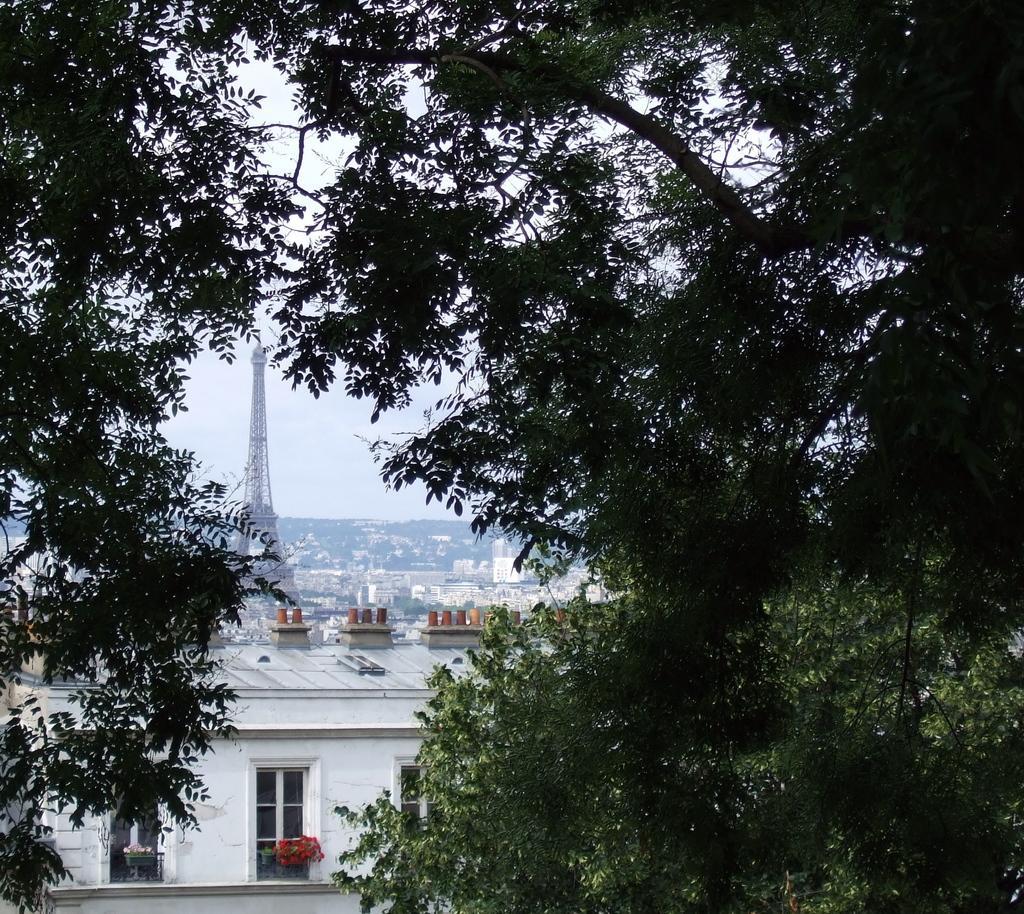Could you give a brief overview of what you see in this image? In this picture I can observe some trees. There is a tower on the left side. I can observe some buildings. In the background there is a sky. 